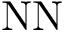<formula> <loc_0><loc_0><loc_500><loc_500>N N</formula> 